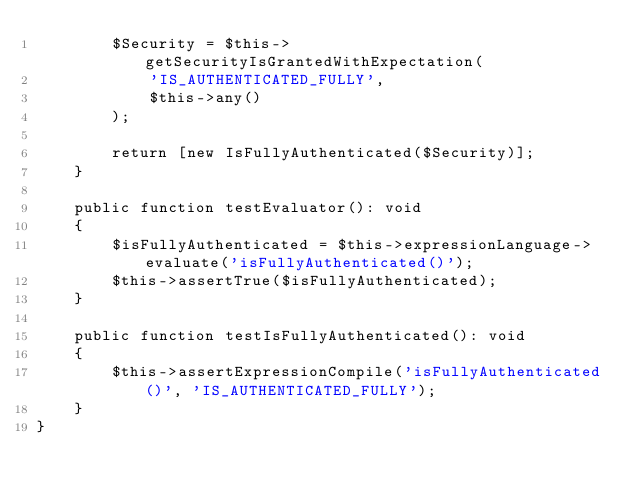<code> <loc_0><loc_0><loc_500><loc_500><_PHP_>        $Security = $this->getSecurityIsGrantedWithExpectation(
            'IS_AUTHENTICATED_FULLY',
            $this->any()
        );

        return [new IsFullyAuthenticated($Security)];
    }

    public function testEvaluator(): void
    {
        $isFullyAuthenticated = $this->expressionLanguage->evaluate('isFullyAuthenticated()');
        $this->assertTrue($isFullyAuthenticated);
    }

    public function testIsFullyAuthenticated(): void
    {
        $this->assertExpressionCompile('isFullyAuthenticated()', 'IS_AUTHENTICATED_FULLY');
    }
}
</code> 